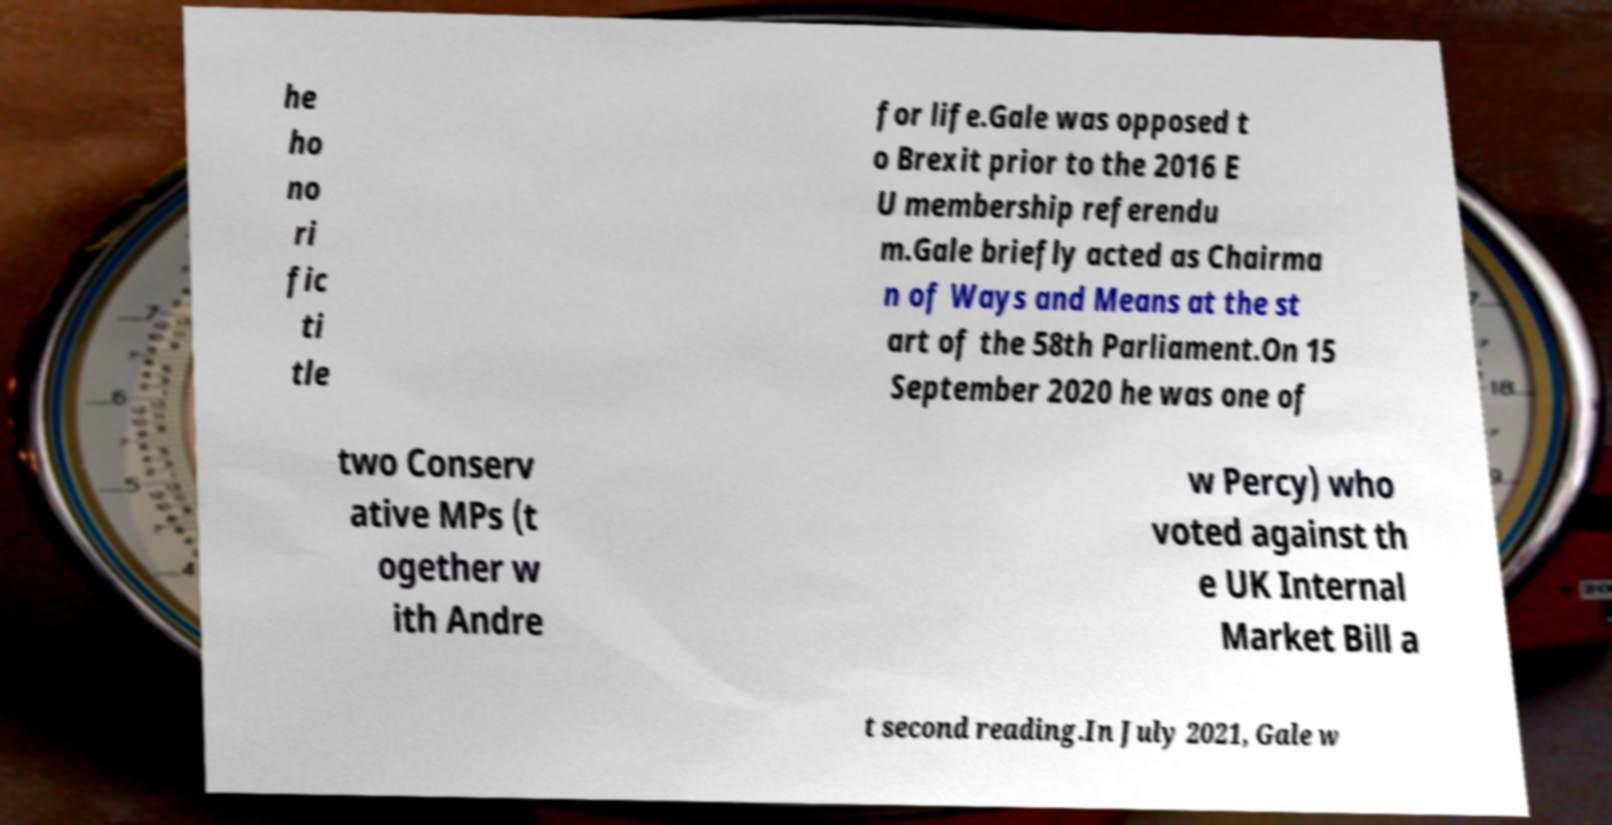Can you accurately transcribe the text from the provided image for me? he ho no ri fic ti tle for life.Gale was opposed t o Brexit prior to the 2016 E U membership referendu m.Gale briefly acted as Chairma n of Ways and Means at the st art of the 58th Parliament.On 15 September 2020 he was one of two Conserv ative MPs (t ogether w ith Andre w Percy) who voted against th e UK Internal Market Bill a t second reading.In July 2021, Gale w 